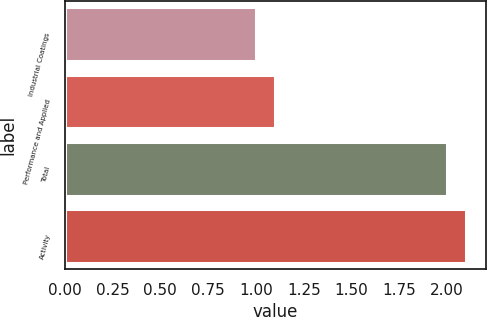<chart> <loc_0><loc_0><loc_500><loc_500><bar_chart><fcel>Industrial Coatings<fcel>Performance and Applied<fcel>Total<fcel>Activity<nl><fcel>1<fcel>1.1<fcel>2<fcel>2.1<nl></chart> 